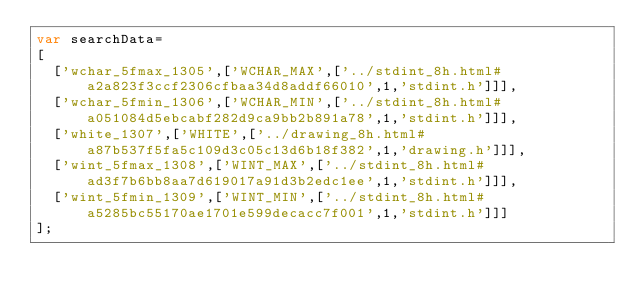Convert code to text. <code><loc_0><loc_0><loc_500><loc_500><_JavaScript_>var searchData=
[
  ['wchar_5fmax_1305',['WCHAR_MAX',['../stdint_8h.html#a2a823f3ccf2306cfbaa34d8addf66010',1,'stdint.h']]],
  ['wchar_5fmin_1306',['WCHAR_MIN',['../stdint_8h.html#a051084d5ebcabf282d9ca9bb2b891a78',1,'stdint.h']]],
  ['white_1307',['WHITE',['../drawing_8h.html#a87b537f5fa5c109d3c05c13d6b18f382',1,'drawing.h']]],
  ['wint_5fmax_1308',['WINT_MAX',['../stdint_8h.html#ad3f7b6bb8aa7d619017a91d3b2edc1ee',1,'stdint.h']]],
  ['wint_5fmin_1309',['WINT_MIN',['../stdint_8h.html#a5285bc55170ae1701e599decacc7f001',1,'stdint.h']]]
];
</code> 